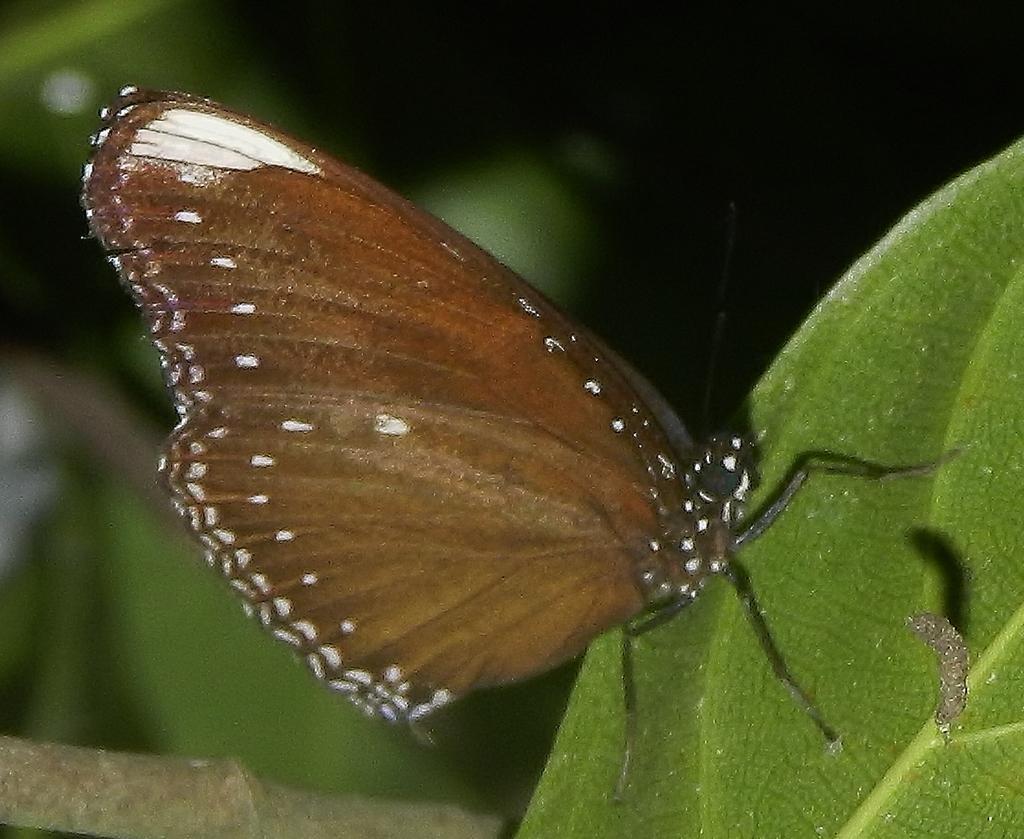How would you summarize this image in a sentence or two? In the picture I can see a butterfly and an insect on the leaf. The background of the image is blurred. 